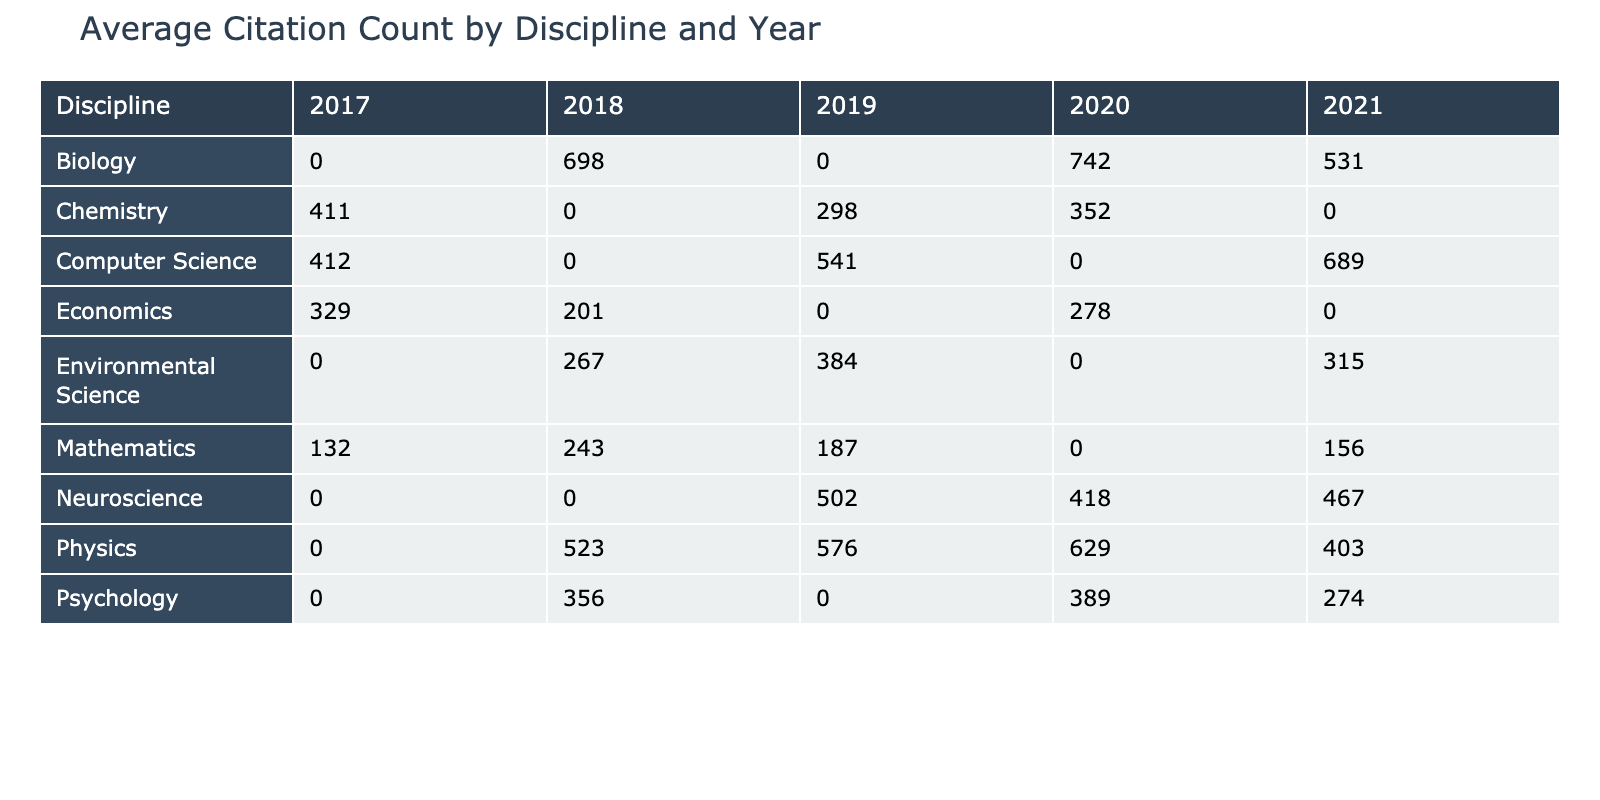What is the average citation count for Biology papers published in 2021? The table shows the citation count for the Biology discipline in 2021 is 531. Since there is only one entry for Biology in 2021, the average citation count is simply 531.
Answer: 531 What was the total citation count for Chemistry papers published in 2019 and 2020? According to the table, the citation count for Chemistry in 2019 is 298, and in 2020 it is 352. Adding these values gives a total of 298 + 352 = 650.
Answer: 650 Is the average citation count for Physics papers higher than that for Economics papers? The average citation counts for Physics can be calculated from 523, 629, 576, and 403, which totals 2131. Dividing by 4 (number of Physics papers) gives an average of 532.75. For Economics, the citation counts are 201 and 278, totalling 479. Dividing by 2 gives an average of 239.5. Since 532.75 is greater than 239.5, the statement is true.
Answer: Yes Which discipline had the highest average citation count across all publication years? To determine this, we need to calculate the average citation counts for each discipline. After calculating averages: Physics (532.75), Mathematics (191.5), Biology (620.33), Chemistry (387.33), Computer Science (512.33), Psychology (339.75), Economics (239.5), Neuroscience (468.5), and Environmental Science (292). Biology has the highest average at 620.33.
Answer: Biology How many papers published in 2018 had a citation count greater than 300? Referring to the table, we find the citation counts for 2018: Physics (523), Mathematics (243), Psychology (356), Economics (201), and Biology (698). Out of these, Physics, Psychology, and Biology have counts greater than 300, totaling 3 papers.
Answer: 3 